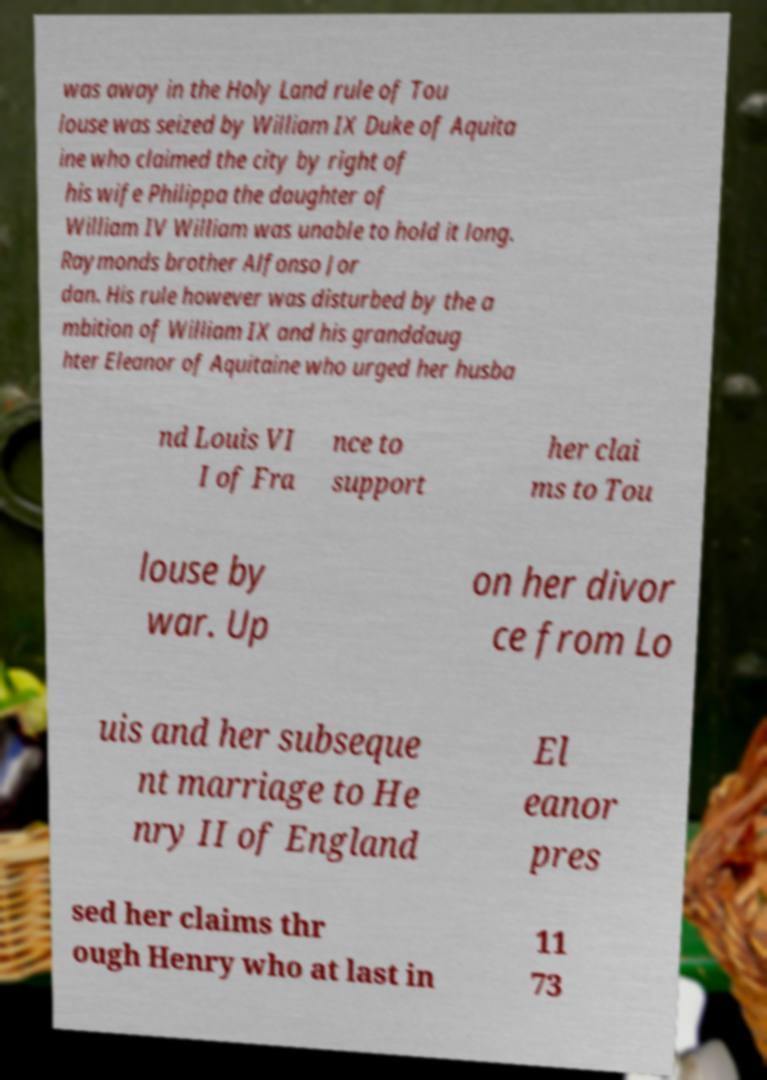What messages or text are displayed in this image? I need them in a readable, typed format. was away in the Holy Land rule of Tou louse was seized by William IX Duke of Aquita ine who claimed the city by right of his wife Philippa the daughter of William IV William was unable to hold it long. Raymonds brother Alfonso Jor dan. His rule however was disturbed by the a mbition of William IX and his granddaug hter Eleanor of Aquitaine who urged her husba nd Louis VI I of Fra nce to support her clai ms to Tou louse by war. Up on her divor ce from Lo uis and her subseque nt marriage to He nry II of England El eanor pres sed her claims thr ough Henry who at last in 11 73 